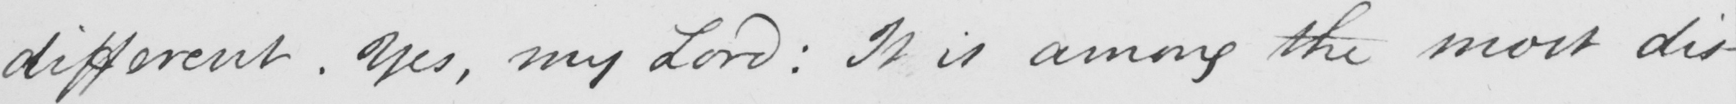Please provide the text content of this handwritten line. different . Yes , my Lord :  It is among the most dis- 